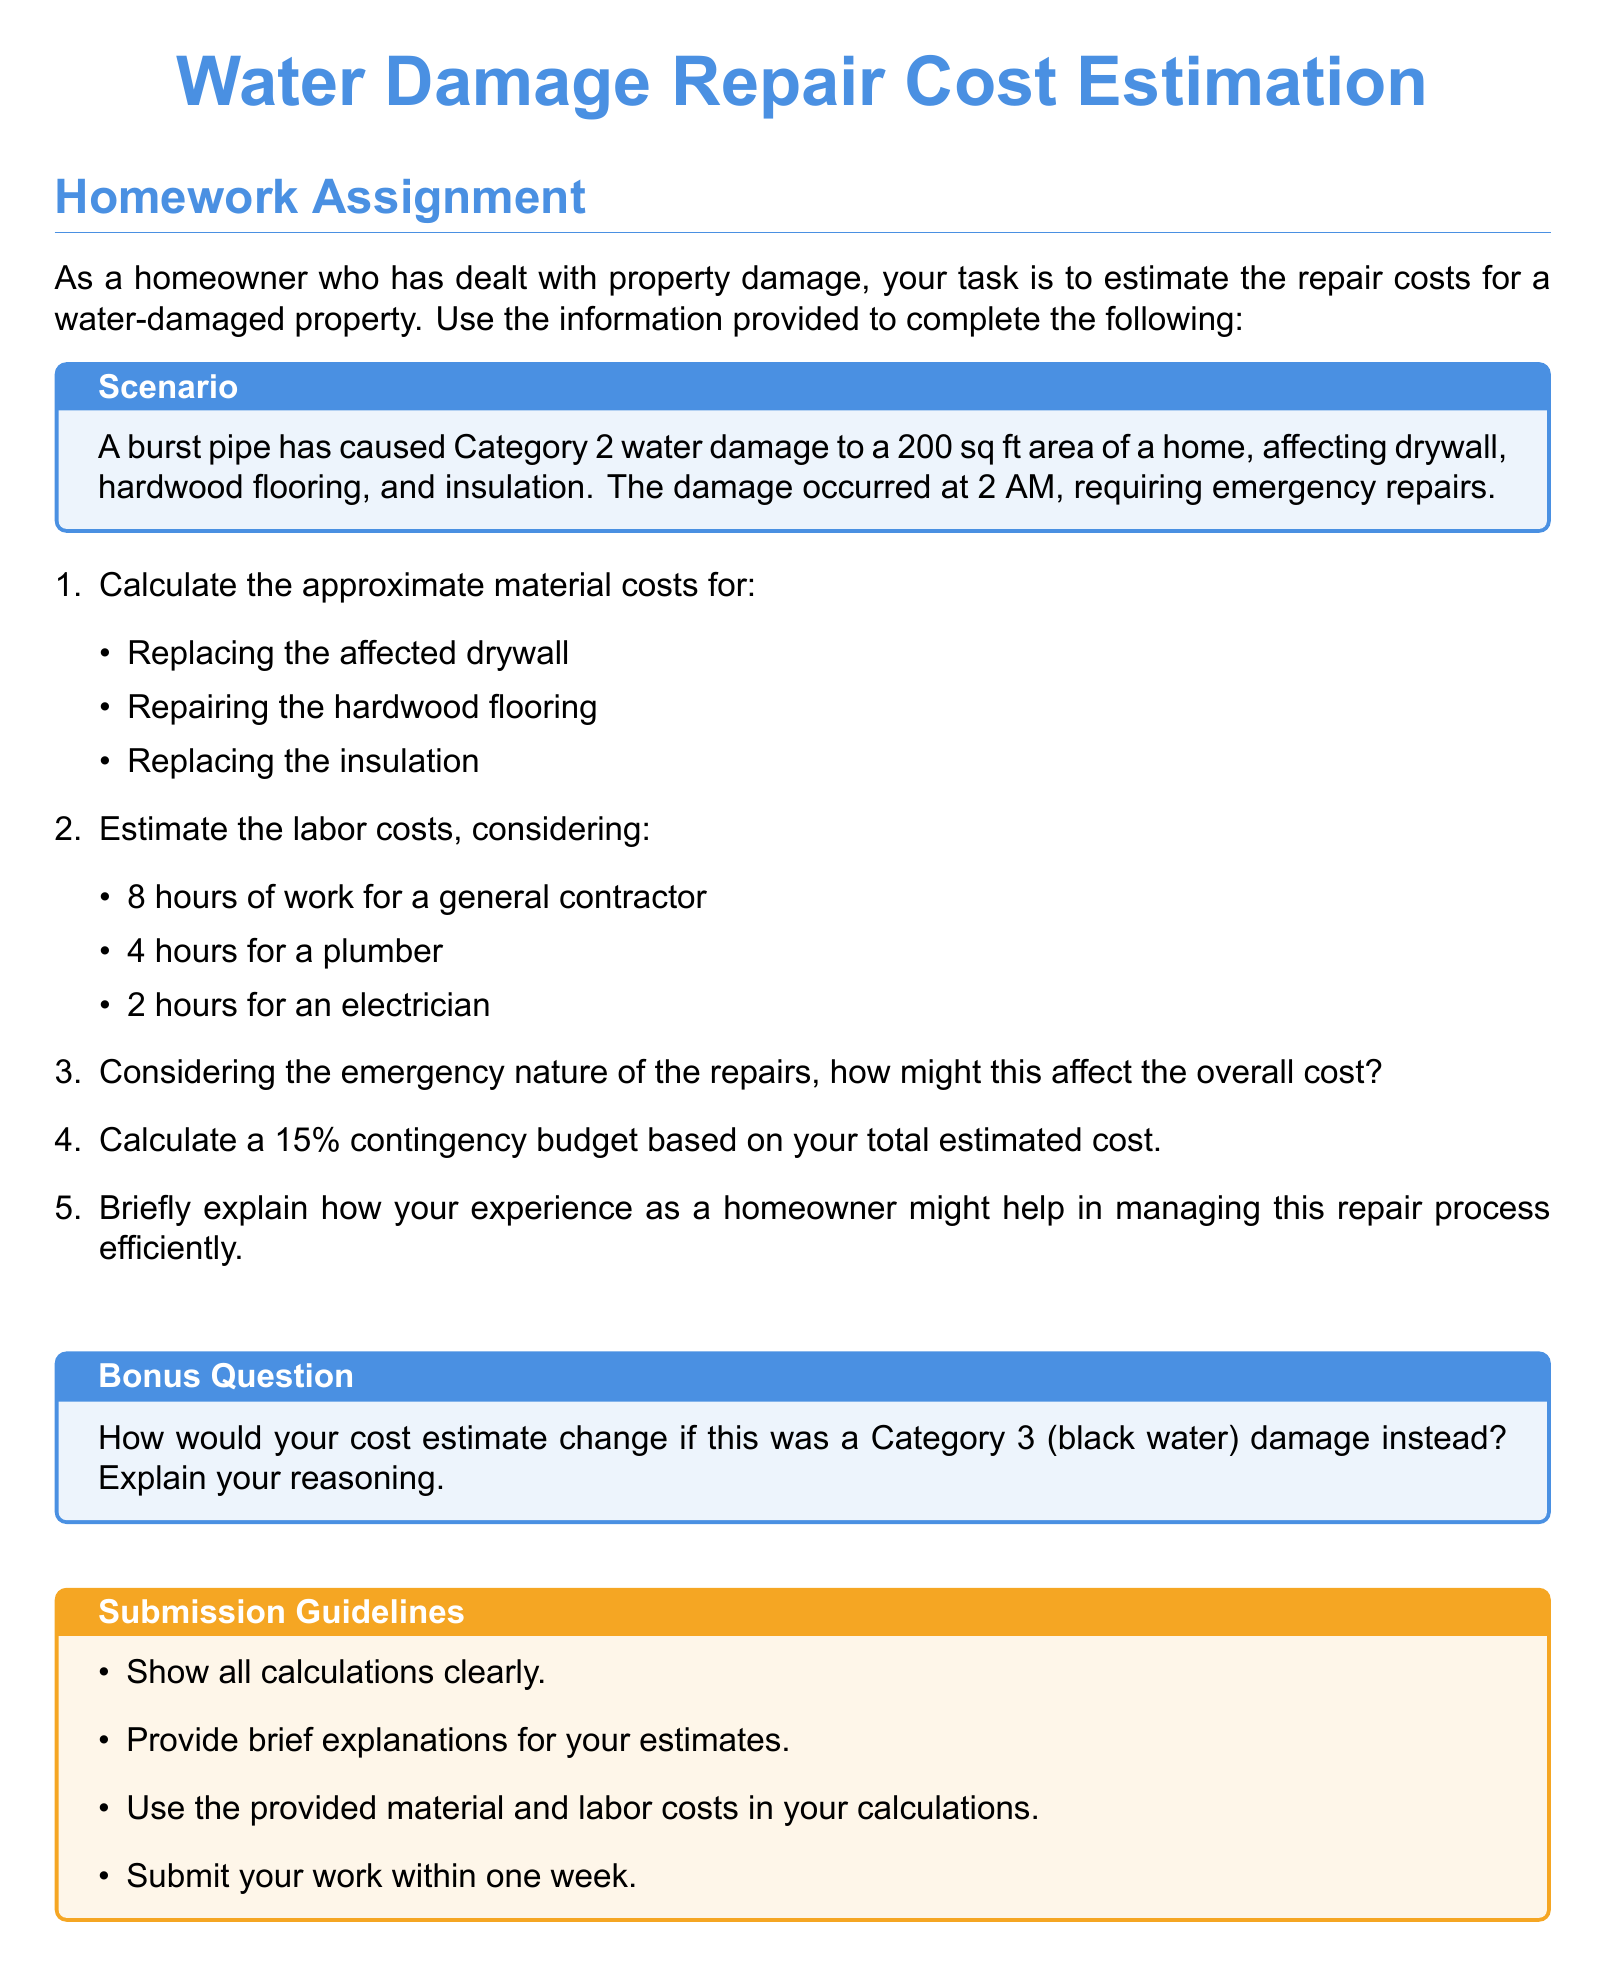What is the size of the affected area? The document states that the area affected by water damage is 200 sq ft.
Answer: 200 sq ft What is the Category of water damage? The scenario describes the water damage as Category 2.
Answer: Category 2 How many hours of work are estimated for the plumber? The document specifies that 4 hours of work is estimated for the plumber.
Answer: 4 hours What is the purpose of calculating a contingency budget? The document suggests a 15% contingency budget for unexpected costs based on the total estimated cost.
Answer: To cover unexpected costs What is the submission deadline for the homework? The document states that the work should be submitted within one week.
Answer: Within one week What type of flooring is mentioned in the scenario? The scenario specifically mentions hardwood flooring as being affected.
Answer: Hardwood flooring How does emergency nature affect overall costs? The document indicates that emergency repairs generally increase overall costs due to urgency and potential overtime.
Answer: Increases costs What additional work would be required for Category 3 damage? The bonus question implies that Category 3 damage would require more extensive health and safety measures, affecting costs.
Answer: More extensive measures What is the labor cost for the general contractor? The document does not specify an exact dollar amount for the general contractor's labor cost, but indicates 8 hours of work.
Answer: Not specified 